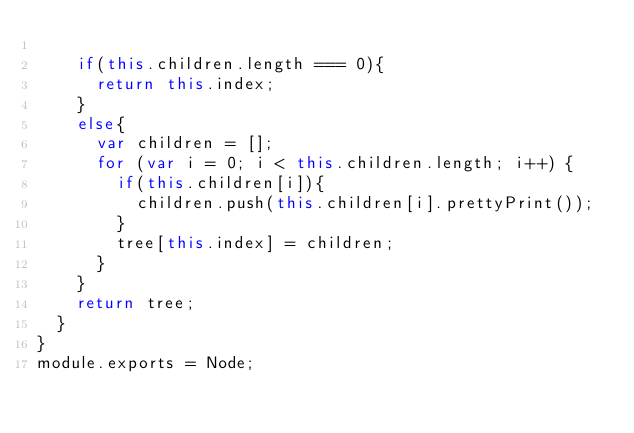Convert code to text. <code><loc_0><loc_0><loc_500><loc_500><_JavaScript_>
    if(this.children.length === 0){
      return this.index;
    }
    else{
      var children = [];
      for (var i = 0; i < this.children.length; i++) {
        if(this.children[i]){
          children.push(this.children[i].prettyPrint());
        }
        tree[this.index] = children;
      }
    }
    return tree;
  }
}
module.exports = Node;
</code> 